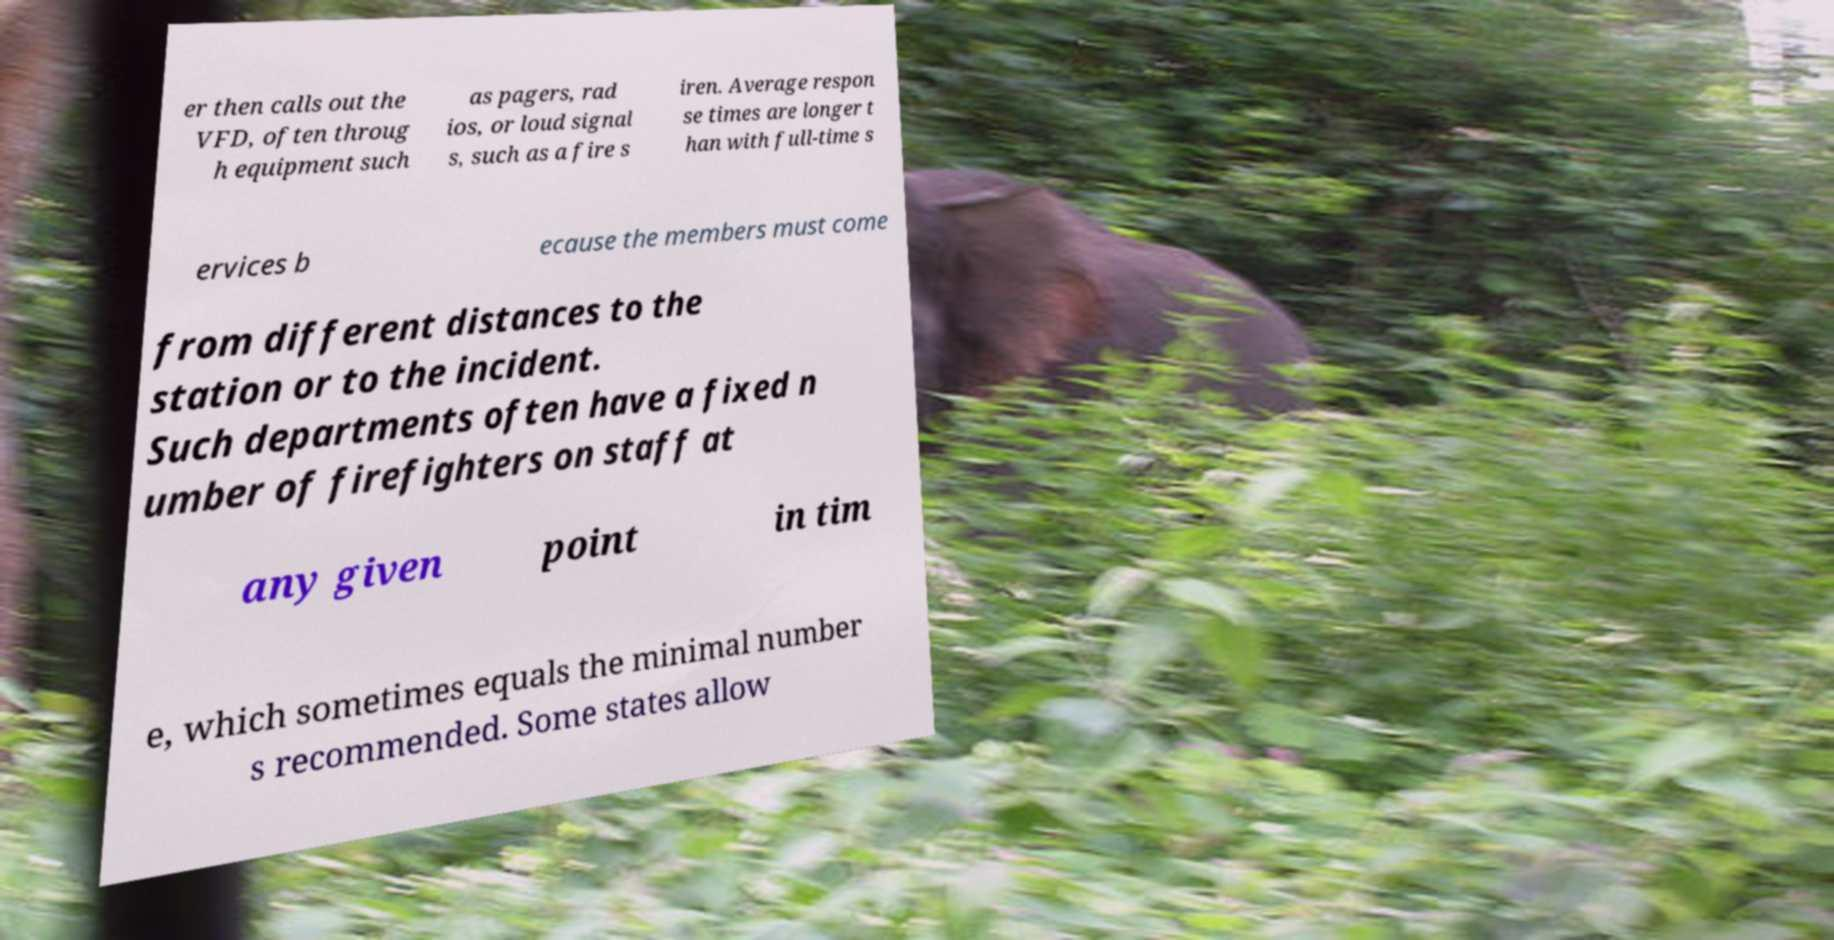I need the written content from this picture converted into text. Can you do that? er then calls out the VFD, often throug h equipment such as pagers, rad ios, or loud signal s, such as a fire s iren. Average respon se times are longer t han with full-time s ervices b ecause the members must come from different distances to the station or to the incident. Such departments often have a fixed n umber of firefighters on staff at any given point in tim e, which sometimes equals the minimal number s recommended. Some states allow 